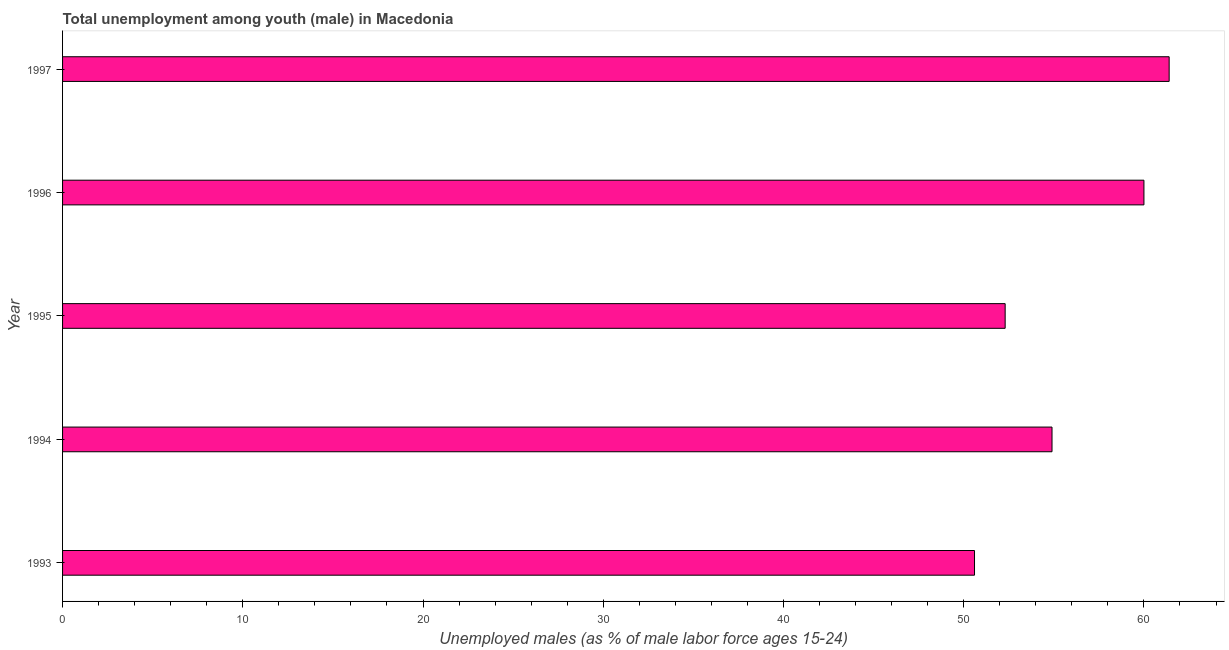Does the graph contain any zero values?
Ensure brevity in your answer.  No. Does the graph contain grids?
Ensure brevity in your answer.  No. What is the title of the graph?
Your answer should be very brief. Total unemployment among youth (male) in Macedonia. What is the label or title of the X-axis?
Give a very brief answer. Unemployed males (as % of male labor force ages 15-24). What is the label or title of the Y-axis?
Provide a succinct answer. Year. What is the unemployed male youth population in 1994?
Keep it short and to the point. 54.9. Across all years, what is the maximum unemployed male youth population?
Offer a terse response. 61.4. Across all years, what is the minimum unemployed male youth population?
Provide a short and direct response. 50.6. In which year was the unemployed male youth population maximum?
Ensure brevity in your answer.  1997. In which year was the unemployed male youth population minimum?
Offer a very short reply. 1993. What is the sum of the unemployed male youth population?
Provide a short and direct response. 279.2. What is the difference between the unemployed male youth population in 1994 and 1997?
Ensure brevity in your answer.  -6.5. What is the average unemployed male youth population per year?
Make the answer very short. 55.84. What is the median unemployed male youth population?
Your response must be concise. 54.9. Do a majority of the years between 1993 and 1996 (inclusive) have unemployed male youth population greater than 60 %?
Your response must be concise. No. What is the ratio of the unemployed male youth population in 1993 to that in 1996?
Offer a very short reply. 0.84. Is the unemployed male youth population in 1995 less than that in 1997?
Make the answer very short. Yes. Is the sum of the unemployed male youth population in 1995 and 1997 greater than the maximum unemployed male youth population across all years?
Your response must be concise. Yes. What is the difference between the highest and the lowest unemployed male youth population?
Offer a terse response. 10.8. In how many years, is the unemployed male youth population greater than the average unemployed male youth population taken over all years?
Provide a succinct answer. 2. Are all the bars in the graph horizontal?
Ensure brevity in your answer.  Yes. What is the difference between two consecutive major ticks on the X-axis?
Ensure brevity in your answer.  10. What is the Unemployed males (as % of male labor force ages 15-24) of 1993?
Keep it short and to the point. 50.6. What is the Unemployed males (as % of male labor force ages 15-24) of 1994?
Provide a succinct answer. 54.9. What is the Unemployed males (as % of male labor force ages 15-24) of 1995?
Provide a succinct answer. 52.3. What is the Unemployed males (as % of male labor force ages 15-24) of 1997?
Your answer should be very brief. 61.4. What is the difference between the Unemployed males (as % of male labor force ages 15-24) in 1993 and 1994?
Provide a succinct answer. -4.3. What is the difference between the Unemployed males (as % of male labor force ages 15-24) in 1993 and 1997?
Your answer should be very brief. -10.8. What is the difference between the Unemployed males (as % of male labor force ages 15-24) in 1994 and 1995?
Offer a terse response. 2.6. What is the difference between the Unemployed males (as % of male labor force ages 15-24) in 1994 and 1997?
Offer a terse response. -6.5. What is the difference between the Unemployed males (as % of male labor force ages 15-24) in 1995 and 1997?
Offer a terse response. -9.1. What is the difference between the Unemployed males (as % of male labor force ages 15-24) in 1996 and 1997?
Your answer should be compact. -1.4. What is the ratio of the Unemployed males (as % of male labor force ages 15-24) in 1993 to that in 1994?
Give a very brief answer. 0.92. What is the ratio of the Unemployed males (as % of male labor force ages 15-24) in 1993 to that in 1996?
Ensure brevity in your answer.  0.84. What is the ratio of the Unemployed males (as % of male labor force ages 15-24) in 1993 to that in 1997?
Provide a short and direct response. 0.82. What is the ratio of the Unemployed males (as % of male labor force ages 15-24) in 1994 to that in 1996?
Make the answer very short. 0.92. What is the ratio of the Unemployed males (as % of male labor force ages 15-24) in 1994 to that in 1997?
Offer a very short reply. 0.89. What is the ratio of the Unemployed males (as % of male labor force ages 15-24) in 1995 to that in 1996?
Give a very brief answer. 0.87. What is the ratio of the Unemployed males (as % of male labor force ages 15-24) in 1995 to that in 1997?
Ensure brevity in your answer.  0.85. 